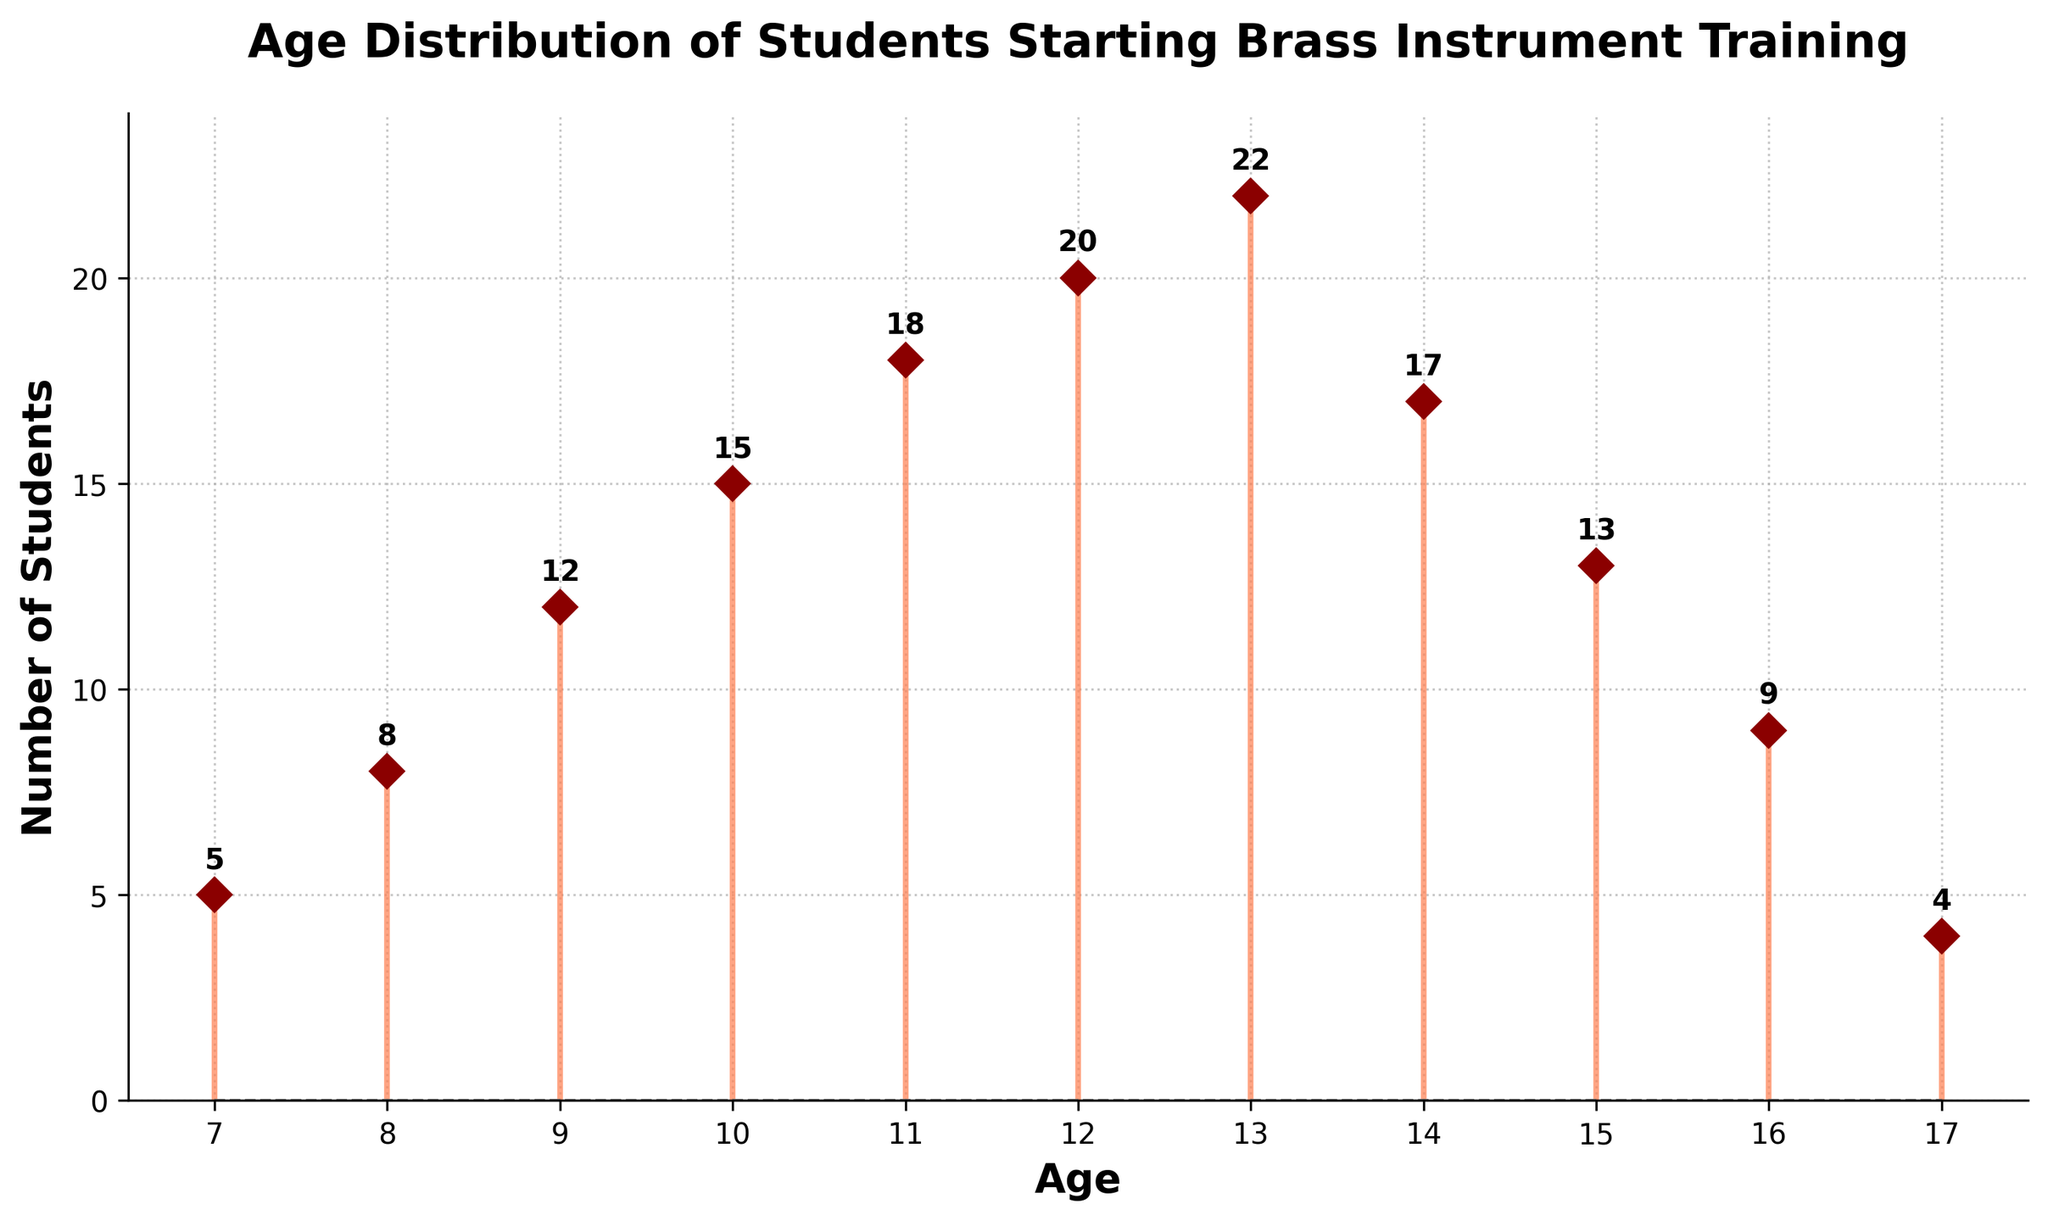What is the title of the plot? The title is typically at the top of the figure. It provides an overview of what the plot represents. The title here is "Age Distribution of Students Starting Brass Instrument Training."
Answer: Age Distribution of Students Starting Brass Instrument Training How many age groups are represented in the plot? This can be determined by counting the unique age data points along the x-axis.
Answer: 11 What is the age with the highest number of students starting brass instrument training? Look for the tallest stem in the plot, which corresponds to the maximum y-value. At age 13, the count is 22, which is the highest.
Answer: 13 What is the age range for students starting brass instrument training in this plot? Identify the minimum and maximum values on the x-axis. The range is from age 7 to age 17.
Answer: 7 to 17 How many students in total are represented in the plot? Sum the counts of all students starting brass instrument training. Summing the y-values (5+8+12+15+18+20+22+17+13+9+4) gives 143.
Answer: 143 What is the second most frequent age for starting brass instrument training? Find the second highest point on the plot. The highest is 13 with 22 students, and the second highest is 14 with 17 students.
Answer: 14 Which two consecutive ages have the largest difference in the number of students? Calculate the difference in student counts for each pair of consecutive ages and find the maximum difference. The largest difference is between ages 13 (22 students) and 12 (20 students), a difference of 2.
Answer: 12 and 13 What is the average number of students starting at ages 10, 11, and 12? Calculate the average of counts for ages 10, 11, and 12. Adding counts (15+18+20) equals 53, dividing by 3 gives approximately 17.67.
Answer: 17.67 What is the percentage of students starting at age 13 compared to the total? Divide the count of age 13 by the total number of students and multiply by 100 to get the percentage. (22 / 143) * 100 is approximately 15.38%.
Answer: 15.38% Which age has the smallest number of students starting brass instrument training? Find the shortest stem in the plot, which corresponds to the minimum y-value. Age 17 has the smallest number, which is 4.
Answer: 17 